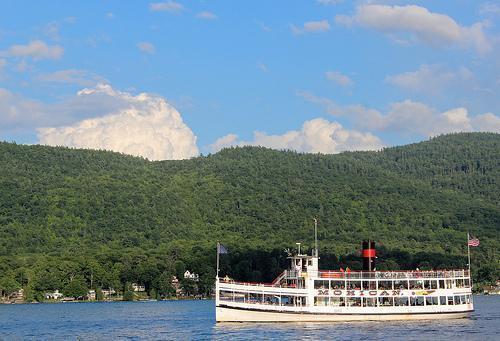How many boats are on the water?
Give a very brief answer. 1. 